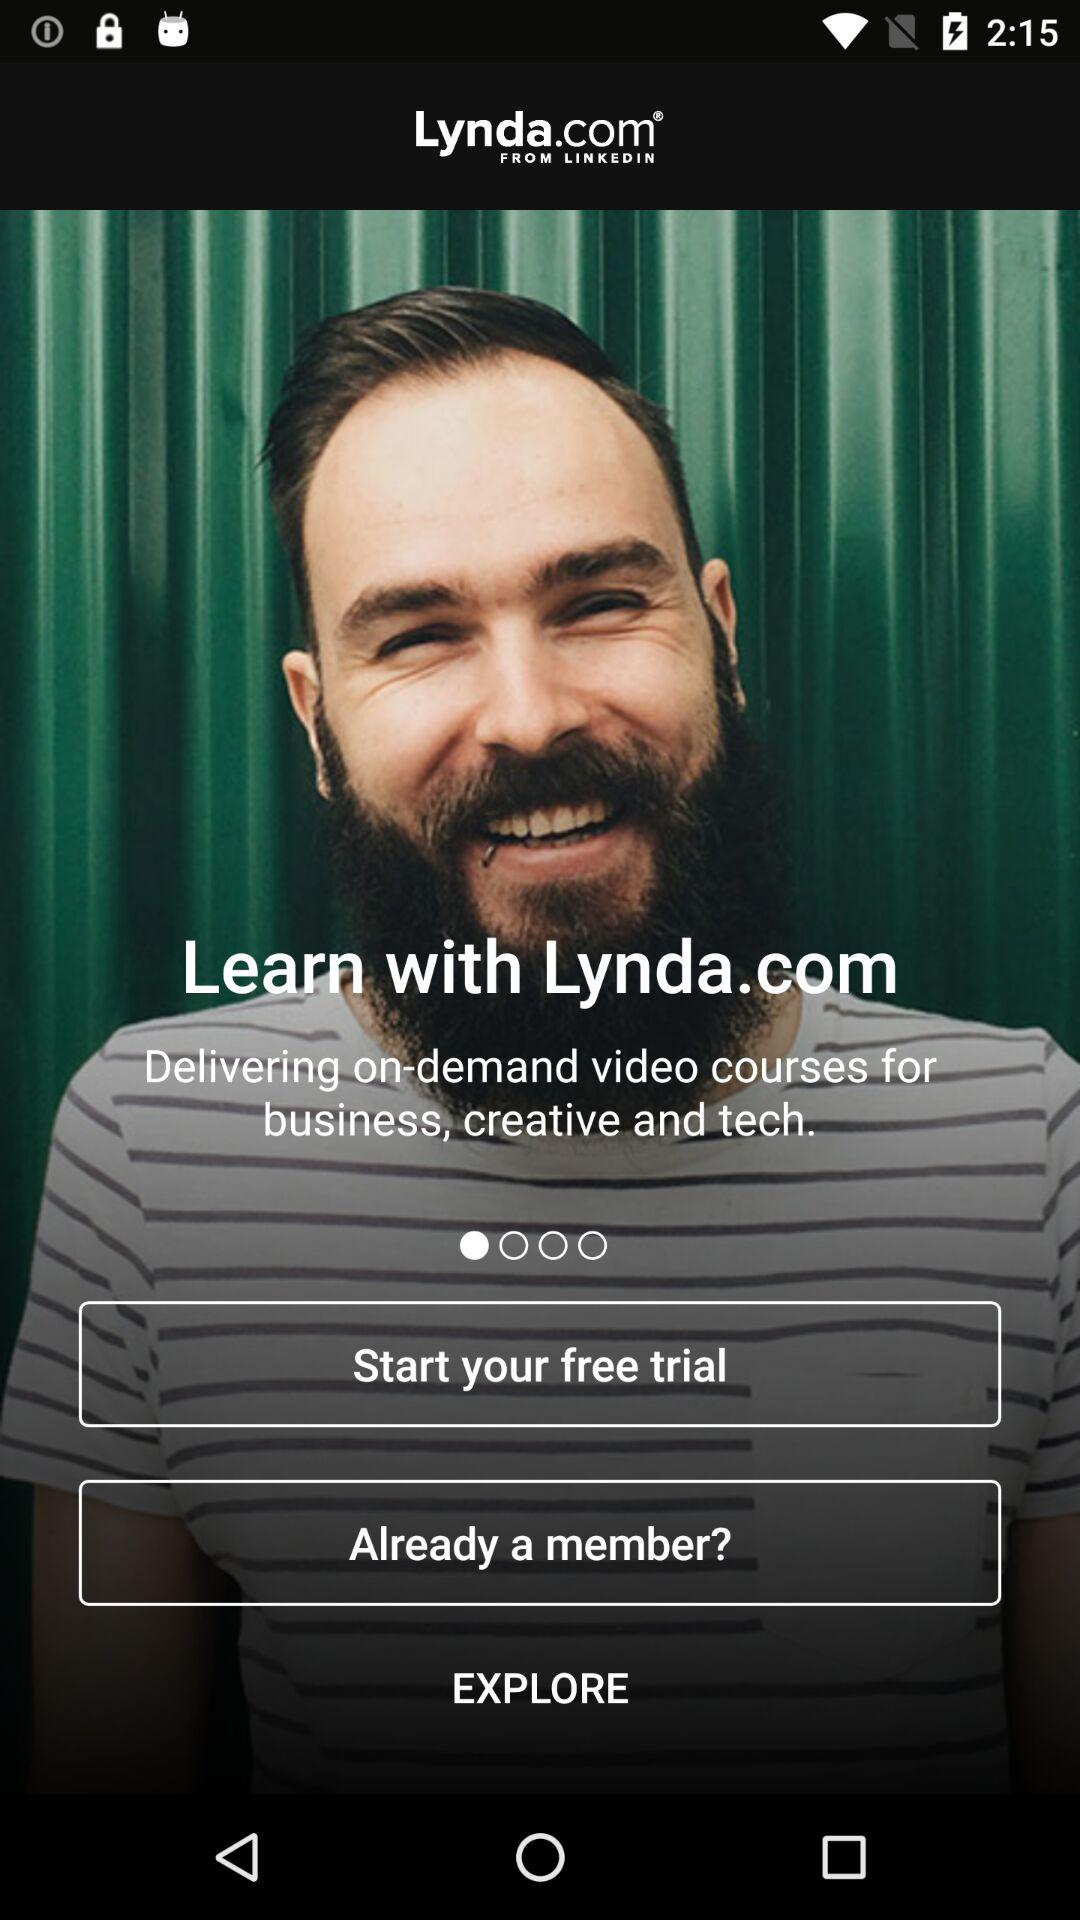What is the application name? The application name is "Lynda.com". 